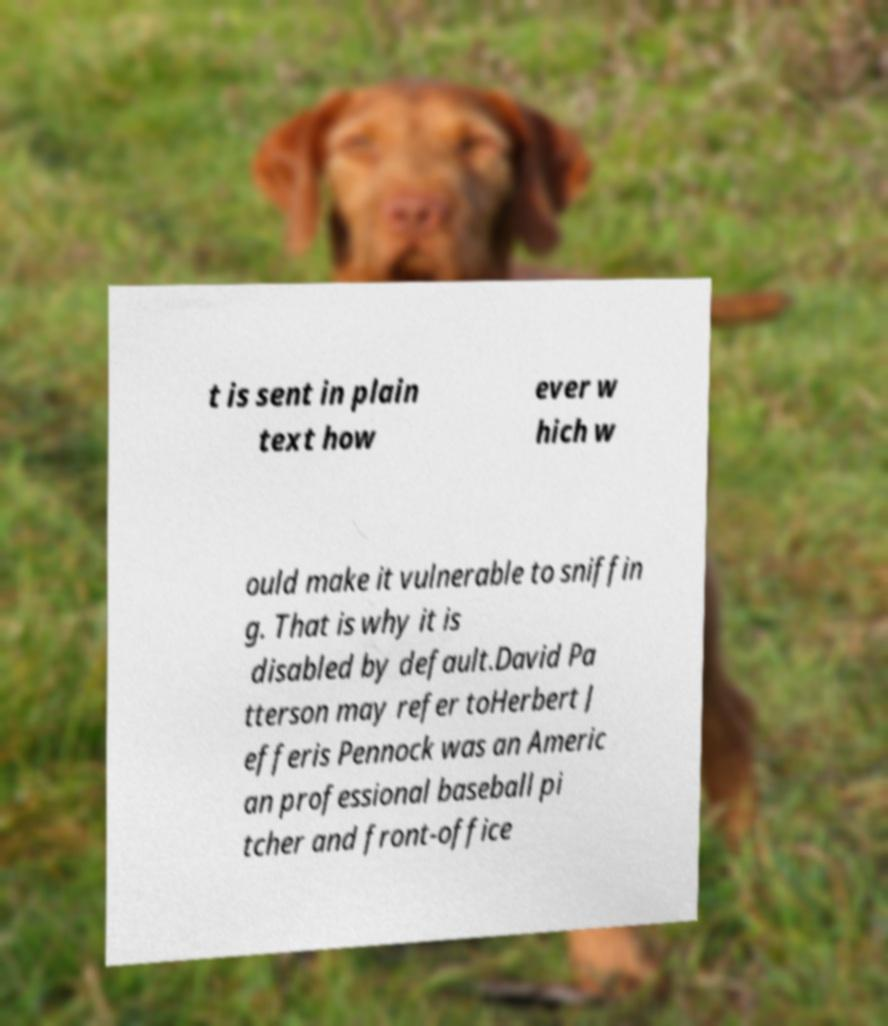For documentation purposes, I need the text within this image transcribed. Could you provide that? t is sent in plain text how ever w hich w ould make it vulnerable to sniffin g. That is why it is disabled by default.David Pa tterson may refer toHerbert J efferis Pennock was an Americ an professional baseball pi tcher and front-office 